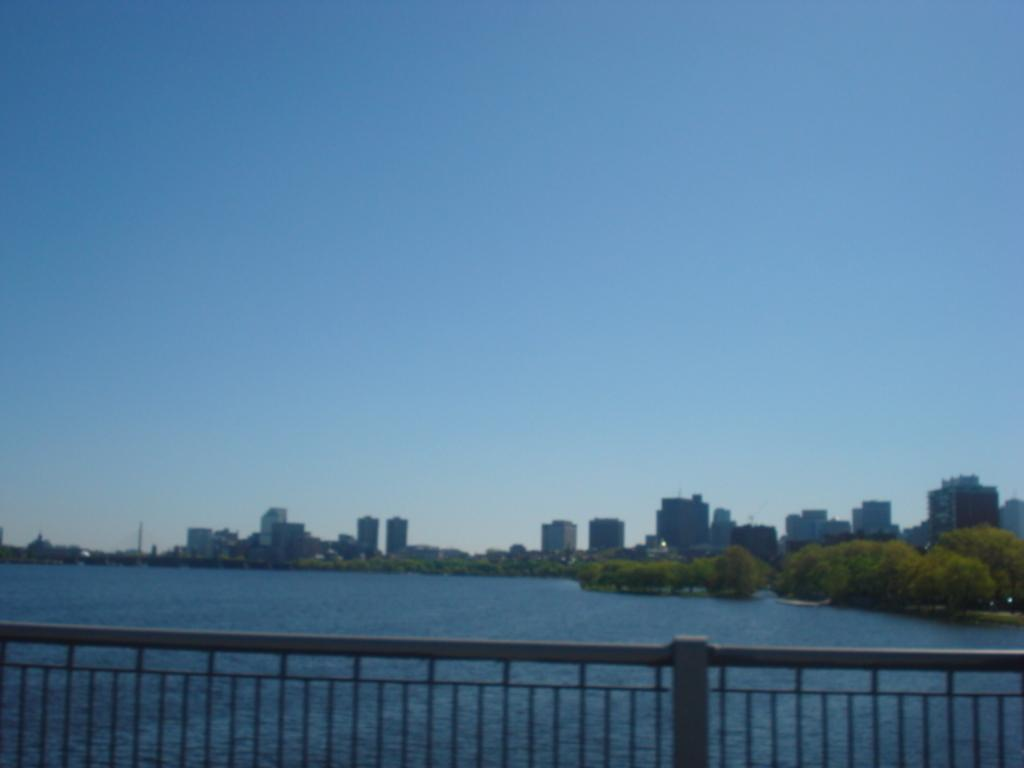What is located at the front of the image? There is a fencing grill in the front of the image. What natural element is visible in the image? There is a river with water visible in the image. What can be seen in the background of the image? There are buildings and green trees in the background of the image. What type of thread is being used to attack the buildings in the image? There is no thread or attack present in the image; it features a fencing grill, a river, buildings, and green trees. Can you tell me how many pickles are floating in the river in the image? There are no pickles present in the image; it features a river with water. 